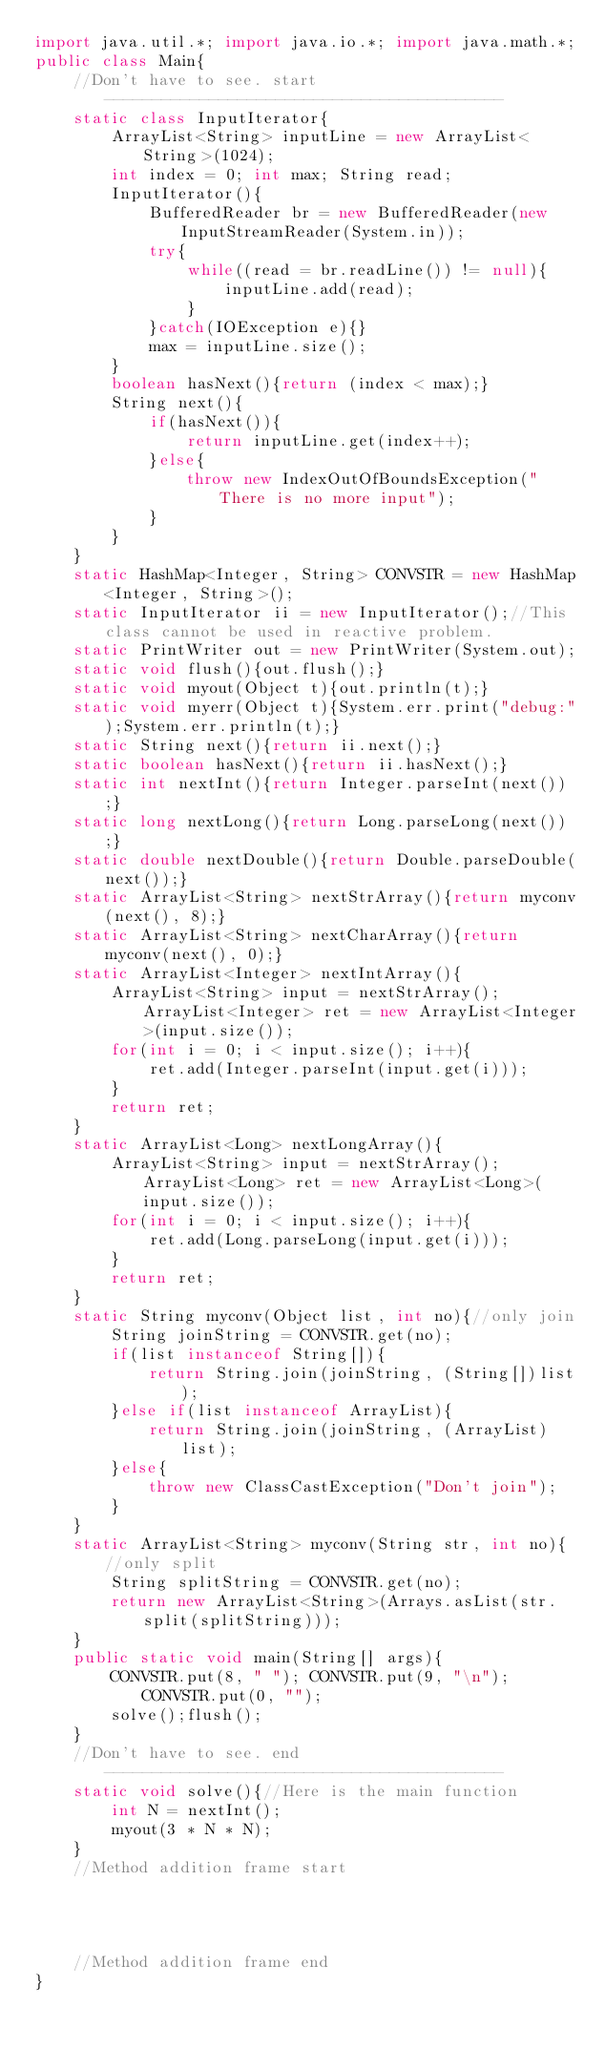Convert code to text. <code><loc_0><loc_0><loc_500><loc_500><_Java_>import java.util.*; import java.io.*; import java.math.*;
public class Main{
	//Don't have to see. start------------------------------------------
	static class InputIterator{
		ArrayList<String> inputLine = new ArrayList<String>(1024);
		int index = 0; int max; String read;
		InputIterator(){
			BufferedReader br = new BufferedReader(new InputStreamReader(System.in));
			try{
				while((read = br.readLine()) != null){
					inputLine.add(read);
				}
			}catch(IOException e){}
			max = inputLine.size();
		}
		boolean hasNext(){return (index < max);}
		String next(){
			if(hasNext()){
				return inputLine.get(index++);
			}else{
				throw new IndexOutOfBoundsException("There is no more input");
			}
		}
	}
	static HashMap<Integer, String> CONVSTR = new HashMap<Integer, String>();
	static InputIterator ii = new InputIterator();//This class cannot be used in reactive problem.
	static PrintWriter out = new PrintWriter(System.out);
	static void flush(){out.flush();}
	static void myout(Object t){out.println(t);}
	static void myerr(Object t){System.err.print("debug:");System.err.println(t);}
	static String next(){return ii.next();}
	static boolean hasNext(){return ii.hasNext();}
	static int nextInt(){return Integer.parseInt(next());}
	static long nextLong(){return Long.parseLong(next());}
	static double nextDouble(){return Double.parseDouble(next());}
	static ArrayList<String> nextStrArray(){return myconv(next(), 8);}
	static ArrayList<String> nextCharArray(){return myconv(next(), 0);}
	static ArrayList<Integer> nextIntArray(){
		ArrayList<String> input = nextStrArray(); ArrayList<Integer> ret = new ArrayList<Integer>(input.size());
		for(int i = 0; i < input.size(); i++){
			ret.add(Integer.parseInt(input.get(i)));
		}
		return ret;
	}
	static ArrayList<Long> nextLongArray(){
		ArrayList<String> input = nextStrArray(); ArrayList<Long> ret = new ArrayList<Long>(input.size());
		for(int i = 0; i < input.size(); i++){
			ret.add(Long.parseLong(input.get(i)));
		}
		return ret;
	}
	static String myconv(Object list, int no){//only join
		String joinString = CONVSTR.get(no);
		if(list instanceof String[]){
			return String.join(joinString, (String[])list);
		}else if(list instanceof ArrayList){
			return String.join(joinString, (ArrayList)list);
		}else{
			throw new ClassCastException("Don't join");
		}
	}
	static ArrayList<String> myconv(String str, int no){//only split
		String splitString = CONVSTR.get(no);
		return new ArrayList<String>(Arrays.asList(str.split(splitString)));
	}
	public static void main(String[] args){
		CONVSTR.put(8, " "); CONVSTR.put(9, "\n"); CONVSTR.put(0, "");
		solve();flush();
	}
	//Don't have to see. end------------------------------------------
	static void solve(){//Here is the main function
		int N = nextInt();
		myout(3 * N * N);
	}
	//Method addition frame start




	//Method addition frame end
}
</code> 